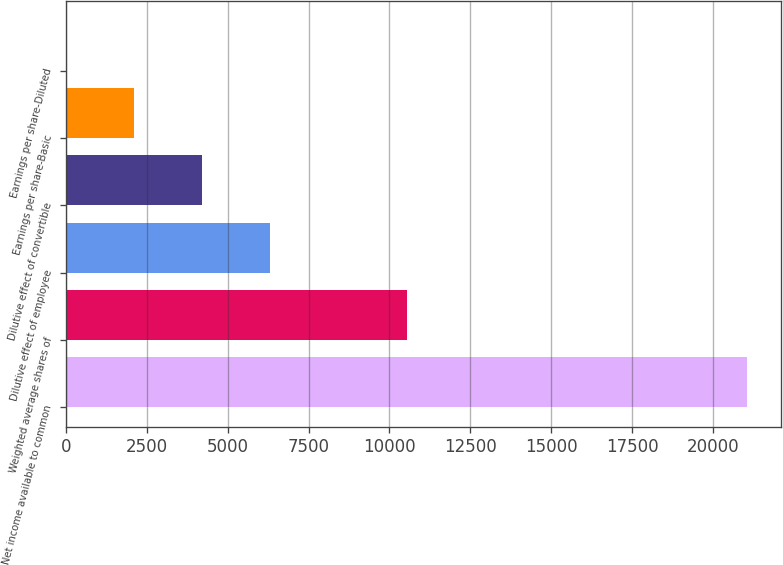<chart> <loc_0><loc_0><loc_500><loc_500><bar_chart><fcel>Net income available to common<fcel>Weighted average shares of<fcel>Dilutive effect of employee<fcel>Dilutive effect of convertible<fcel>Earnings per share-Basic<fcel>Earnings per share-Diluted<nl><fcel>21053<fcel>10528.7<fcel>6319.03<fcel>4214.18<fcel>2109.33<fcel>4.48<nl></chart> 